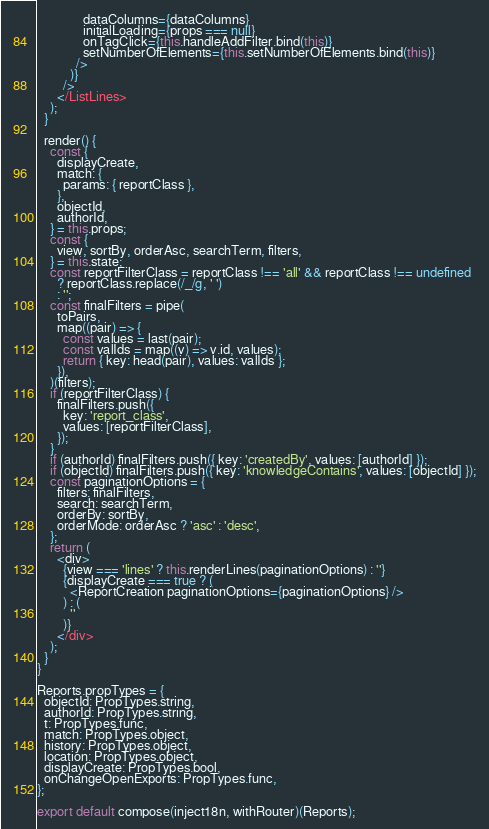<code> <loc_0><loc_0><loc_500><loc_500><_JavaScript_>              dataColumns={dataColumns}
              initialLoading={props === null}
              onTagClick={this.handleAddFilter.bind(this)}
              setNumberOfElements={this.setNumberOfElements.bind(this)}
            />
          )}
        />
      </ListLines>
    );
  }

  render() {
    const {
      displayCreate,
      match: {
        params: { reportClass },
      },
      objectId,
      authorId,
    } = this.props;
    const {
      view, sortBy, orderAsc, searchTerm, filters,
    } = this.state;
    const reportFilterClass = reportClass !== 'all' && reportClass !== undefined
      ? reportClass.replace(/_/g, ' ')
      : '';
    const finalFilters = pipe(
      toPairs,
      map((pair) => {
        const values = last(pair);
        const valIds = map((v) => v.id, values);
        return { key: head(pair), values: valIds };
      }),
    )(filters);
    if (reportFilterClass) {
      finalFilters.push({
        key: 'report_class',
        values: [reportFilterClass],
      });
    }
    if (authorId) finalFilters.push({ key: 'createdBy', values: [authorId] });
    if (objectId) finalFilters.push({ key: 'knowledgeContains', values: [objectId] });
    const paginationOptions = {
      filters: finalFilters,
      search: searchTerm,
      orderBy: sortBy,
      orderMode: orderAsc ? 'asc' : 'desc',
    };
    return (
      <div>
        {view === 'lines' ? this.renderLines(paginationOptions) : ''}
        {displayCreate === true ? (
          <ReportCreation paginationOptions={paginationOptions} />
        ) : (
          ''
        )}
      </div>
    );
  }
}

Reports.propTypes = {
  objectId: PropTypes.string,
  authorId: PropTypes.string,
  t: PropTypes.func,
  match: PropTypes.object,
  history: PropTypes.object,
  location: PropTypes.object,
  displayCreate: PropTypes.bool,
  onChangeOpenExports: PropTypes.func,
};

export default compose(inject18n, withRouter)(Reports);
</code> 